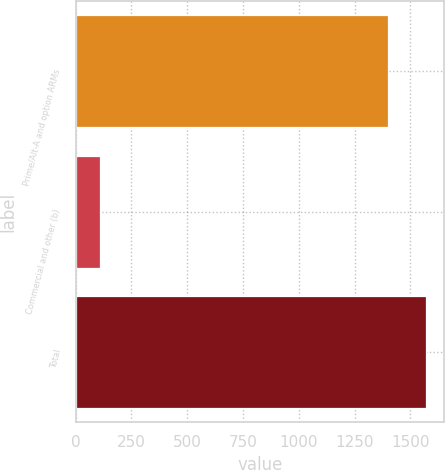<chart> <loc_0><loc_0><loc_500><loc_500><bar_chart><fcel>Prime/Alt-A and option ARMs<fcel>Commercial and other (b)<fcel>Total<nl><fcel>1400<fcel>107<fcel>1571<nl></chart> 